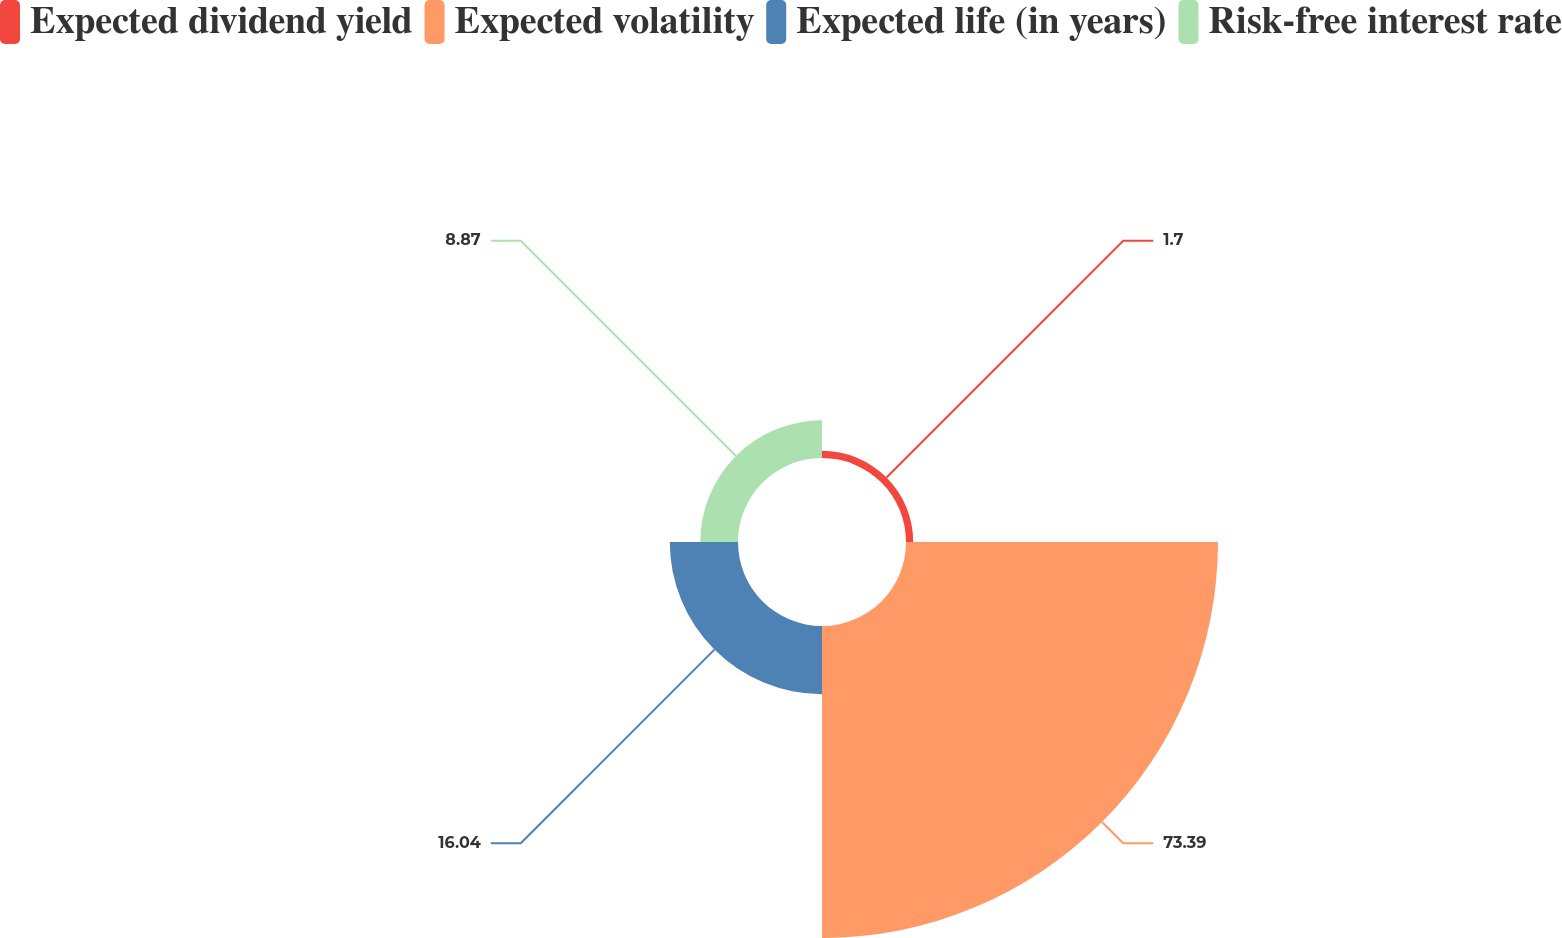Convert chart to OTSL. <chart><loc_0><loc_0><loc_500><loc_500><pie_chart><fcel>Expected dividend yield<fcel>Expected volatility<fcel>Expected life (in years)<fcel>Risk-free interest rate<nl><fcel>1.7%<fcel>73.39%<fcel>16.04%<fcel>8.87%<nl></chart> 